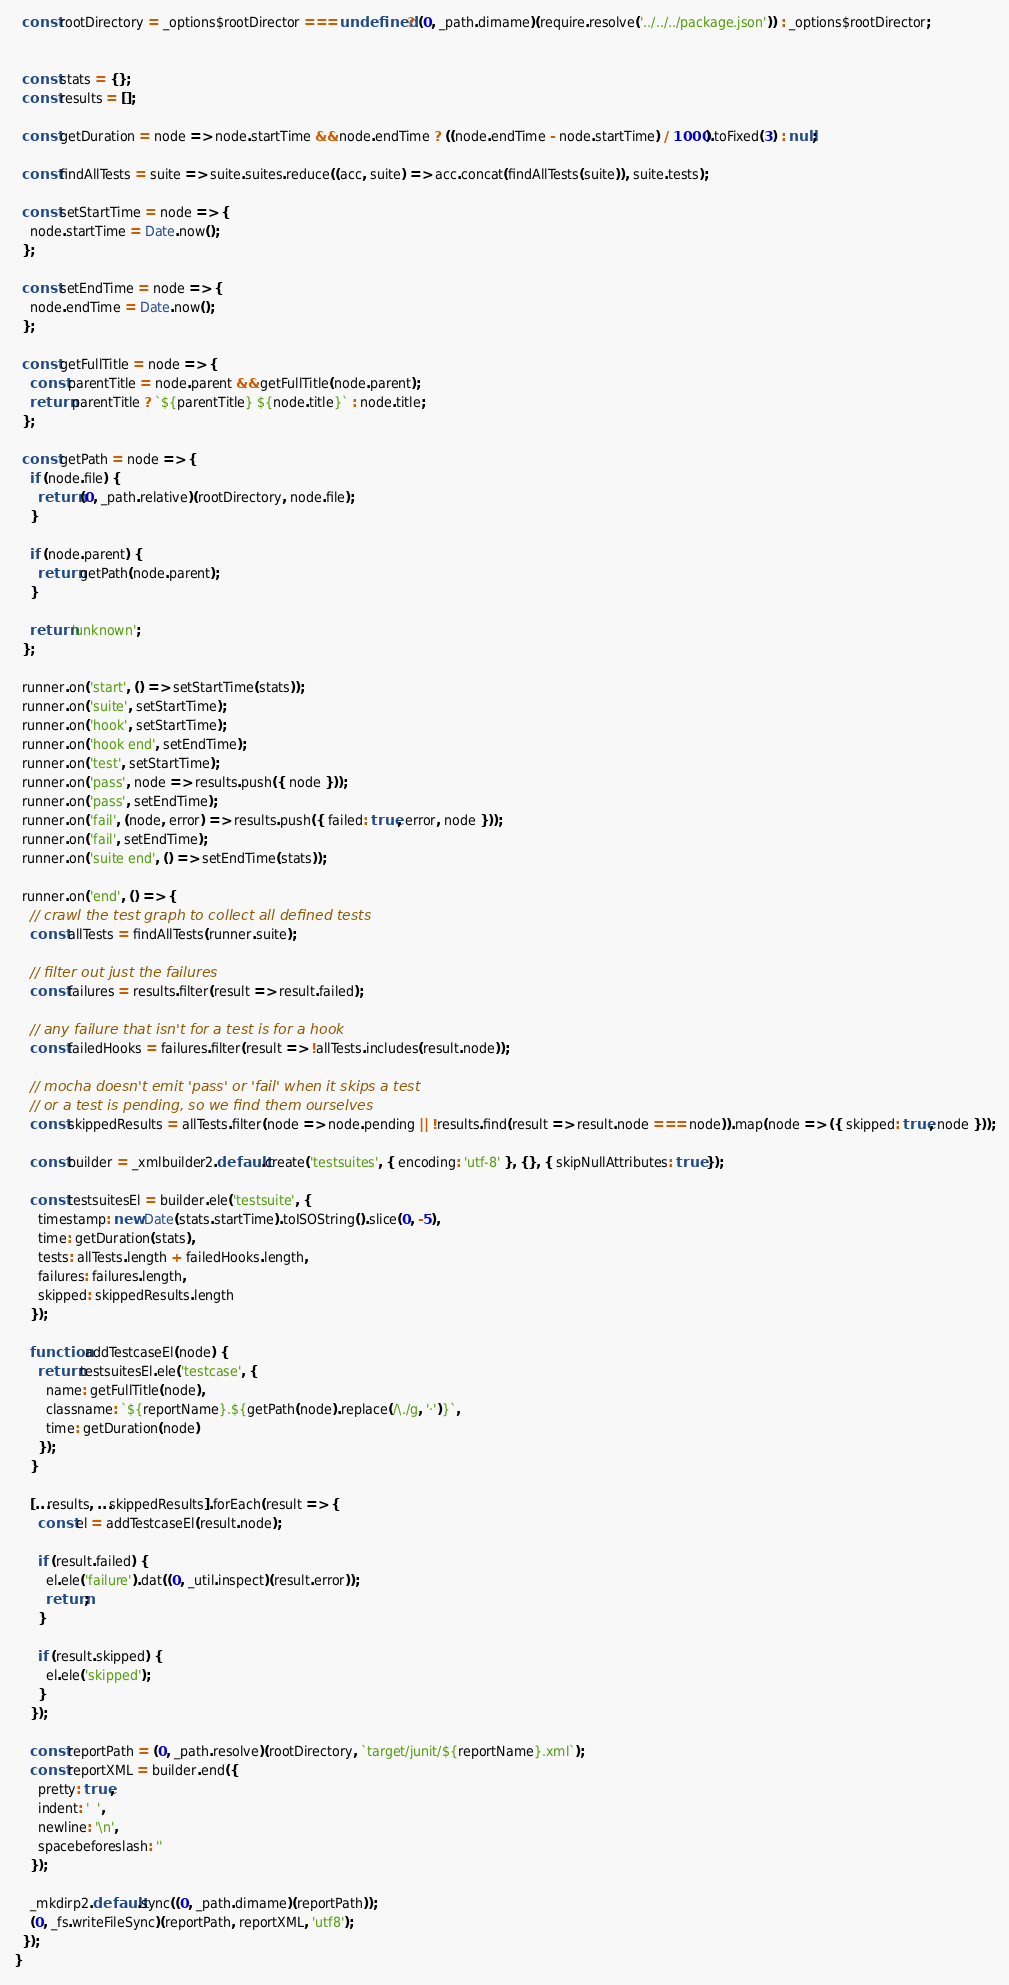<code> <loc_0><loc_0><loc_500><loc_500><_JavaScript_>  const rootDirectory = _options$rootDirector === undefined ? (0, _path.dirname)(require.resolve('../../../package.json')) : _options$rootDirector;


  const stats = {};
  const results = [];

  const getDuration = node => node.startTime && node.endTime ? ((node.endTime - node.startTime) / 1000).toFixed(3) : null;

  const findAllTests = suite => suite.suites.reduce((acc, suite) => acc.concat(findAllTests(suite)), suite.tests);

  const setStartTime = node => {
    node.startTime = Date.now();
  };

  const setEndTime = node => {
    node.endTime = Date.now();
  };

  const getFullTitle = node => {
    const parentTitle = node.parent && getFullTitle(node.parent);
    return parentTitle ? `${parentTitle} ${node.title}` : node.title;
  };

  const getPath = node => {
    if (node.file) {
      return (0, _path.relative)(rootDirectory, node.file);
    }

    if (node.parent) {
      return getPath(node.parent);
    }

    return 'unknown';
  };

  runner.on('start', () => setStartTime(stats));
  runner.on('suite', setStartTime);
  runner.on('hook', setStartTime);
  runner.on('hook end', setEndTime);
  runner.on('test', setStartTime);
  runner.on('pass', node => results.push({ node }));
  runner.on('pass', setEndTime);
  runner.on('fail', (node, error) => results.push({ failed: true, error, node }));
  runner.on('fail', setEndTime);
  runner.on('suite end', () => setEndTime(stats));

  runner.on('end', () => {
    // crawl the test graph to collect all defined tests
    const allTests = findAllTests(runner.suite);

    // filter out just the failures
    const failures = results.filter(result => result.failed);

    // any failure that isn't for a test is for a hook
    const failedHooks = failures.filter(result => !allTests.includes(result.node));

    // mocha doesn't emit 'pass' or 'fail' when it skips a test
    // or a test is pending, so we find them ourselves
    const skippedResults = allTests.filter(node => node.pending || !results.find(result => result.node === node)).map(node => ({ skipped: true, node }));

    const builder = _xmlbuilder2.default.create('testsuites', { encoding: 'utf-8' }, {}, { skipNullAttributes: true });

    const testsuitesEl = builder.ele('testsuite', {
      timestamp: new Date(stats.startTime).toISOString().slice(0, -5),
      time: getDuration(stats),
      tests: allTests.length + failedHooks.length,
      failures: failures.length,
      skipped: skippedResults.length
    });

    function addTestcaseEl(node) {
      return testsuitesEl.ele('testcase', {
        name: getFullTitle(node),
        classname: `${reportName}.${getPath(node).replace(/\./g, '·')}`,
        time: getDuration(node)
      });
    }

    [...results, ...skippedResults].forEach(result => {
      const el = addTestcaseEl(result.node);

      if (result.failed) {
        el.ele('failure').dat((0, _util.inspect)(result.error));
        return;
      }

      if (result.skipped) {
        el.ele('skipped');
      }
    });

    const reportPath = (0, _path.resolve)(rootDirectory, `target/junit/${reportName}.xml`);
    const reportXML = builder.end({
      pretty: true,
      indent: '  ',
      newline: '\n',
      spacebeforeslash: ''
    });

    _mkdirp2.default.sync((0, _path.dirname)(reportPath));
    (0, _fs.writeFileSync)(reportPath, reportXML, 'utf8');
  });
}
</code> 